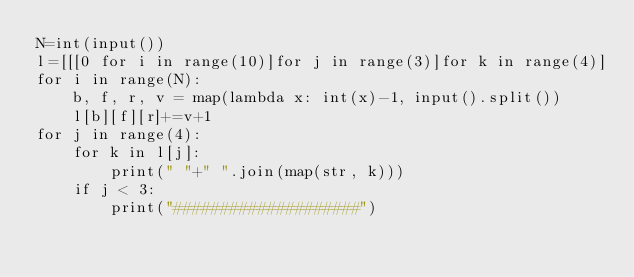Convert code to text. <code><loc_0><loc_0><loc_500><loc_500><_Python_>N=int(input())
l=[[[0 for i in range(10)]for j in range(3)]for k in range(4)]
for i in range(N):
    b, f, r, v = map(lambda x: int(x)-1, input().split())
    l[b][f][r]+=v+1
for j in range(4):
    for k in l[j]:
        print(" "+" ".join(map(str, k)))
    if j < 3:
        print("####################")</code> 